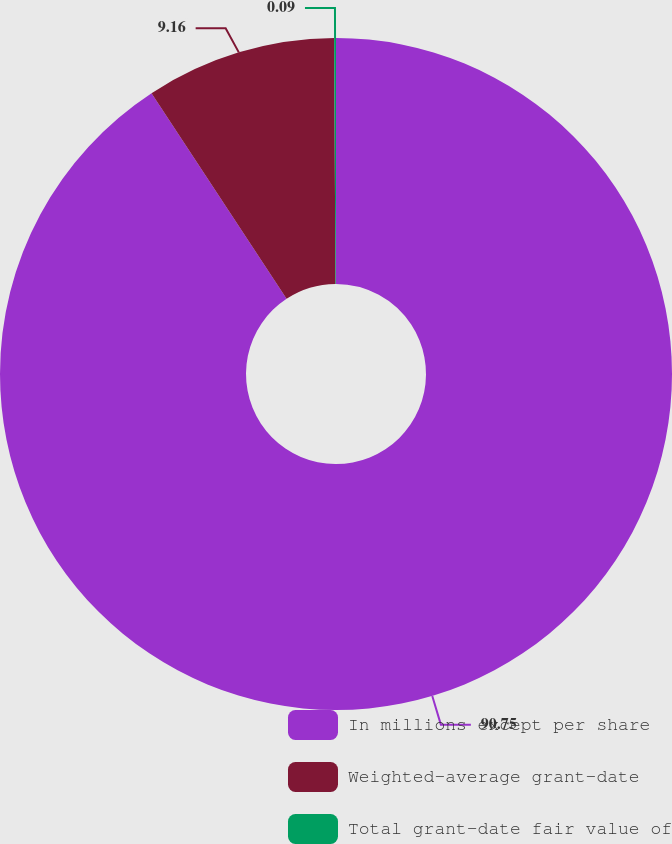<chart> <loc_0><loc_0><loc_500><loc_500><pie_chart><fcel>In millions except per share<fcel>Weighted-average grant-date<fcel>Total grant-date fair value of<nl><fcel>90.75%<fcel>9.16%<fcel>0.09%<nl></chart> 